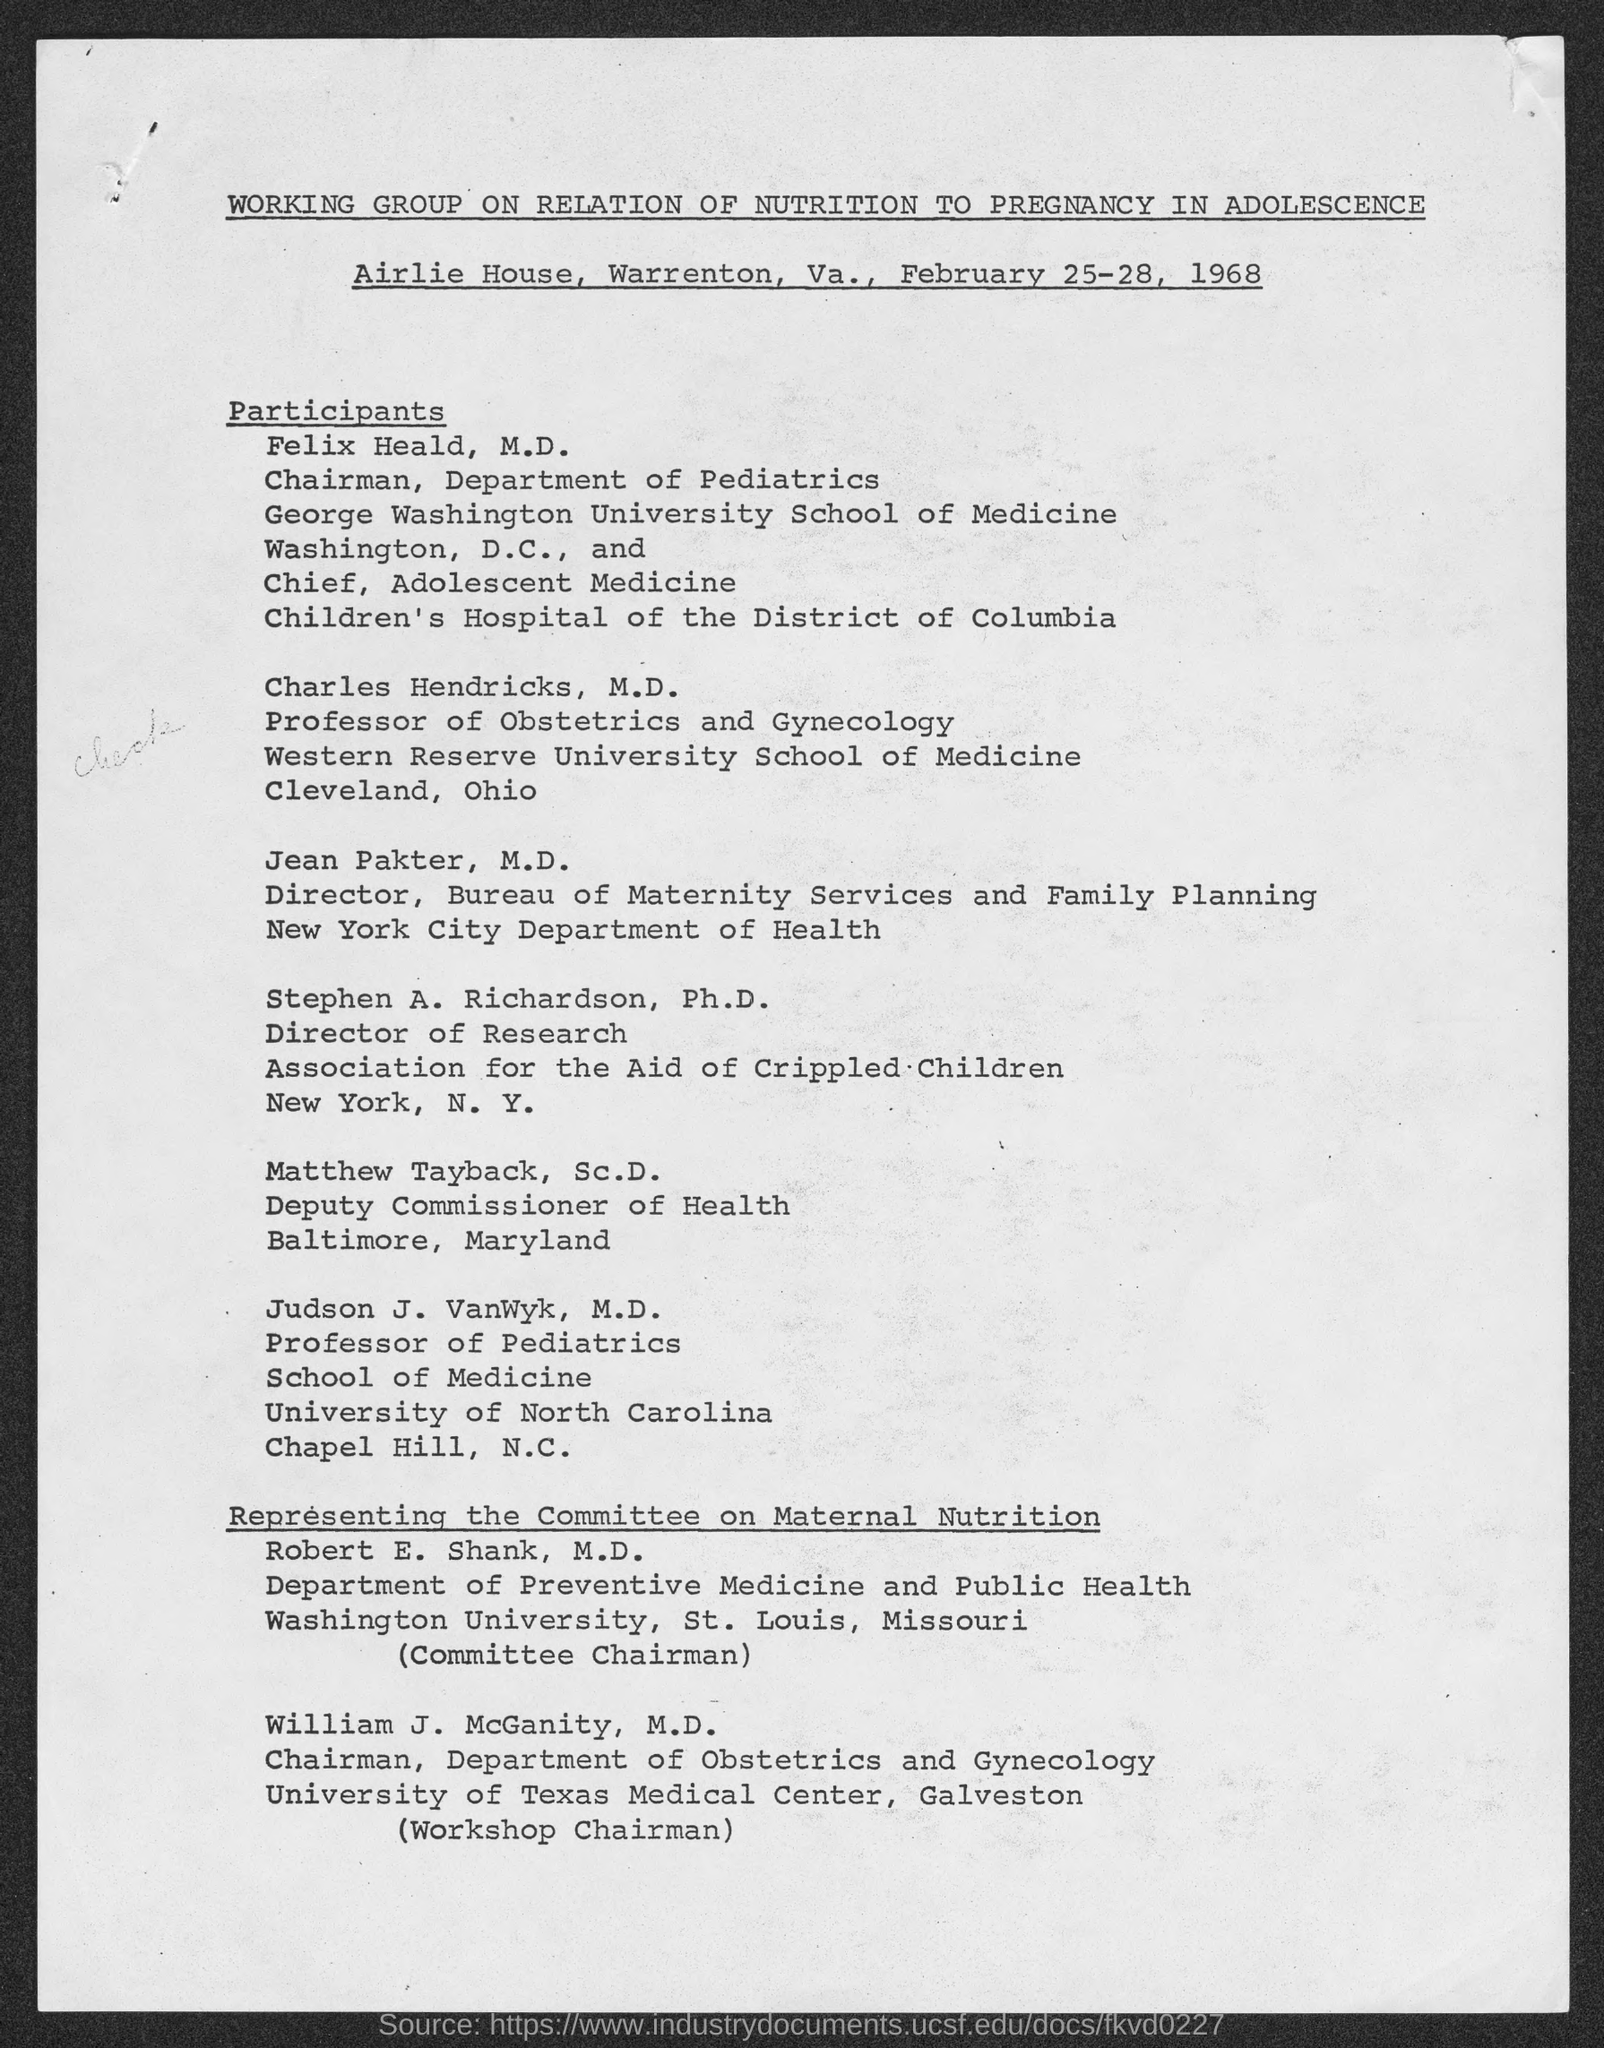Who is the chairman of department of pediatrics?
Keep it short and to the point. Felix Heald. Who is the professor of obstetrics and gynecology?
Offer a very short reply. Charles Hendricks, M.D. Who is the deputy commissioner of health, baltimore, maryland?
Ensure brevity in your answer.  Matthew Tayback, Sc.D. Who is the director, bureau of maternity services and family planning?
Ensure brevity in your answer.  Jean Pakter, M.D. Who is the professor of pediatrics?
Offer a terse response. Judson J. VanWyk. 